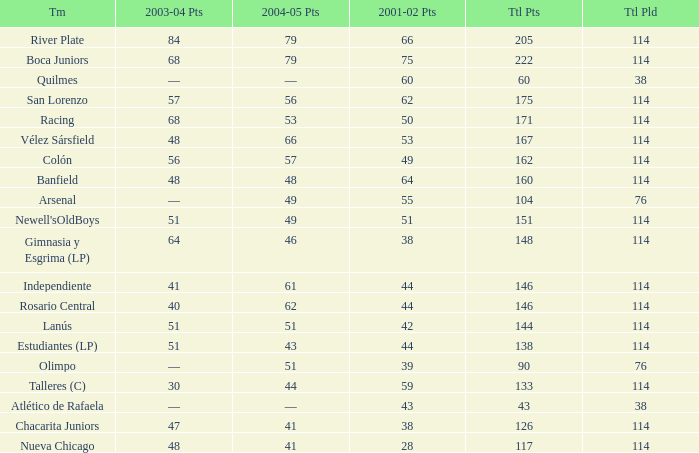Which Total Pts have a 2001–02 Pts smaller than 38? 117.0. 